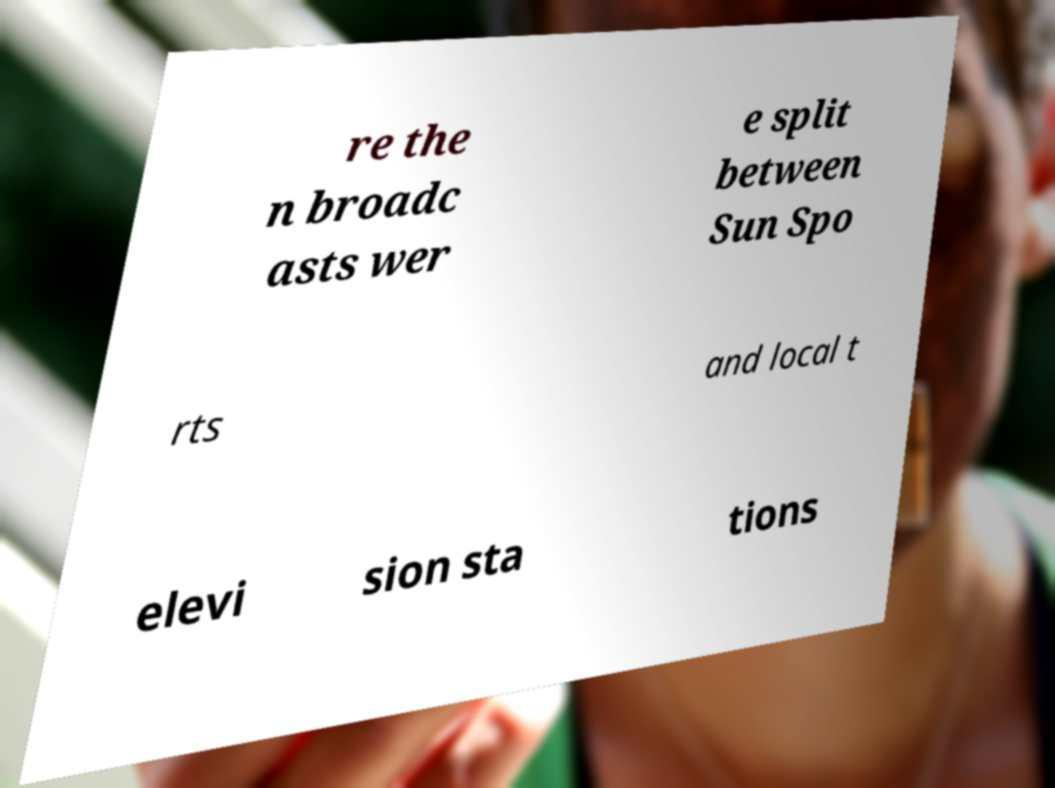Could you extract and type out the text from this image? re the n broadc asts wer e split between Sun Spo rts and local t elevi sion sta tions 